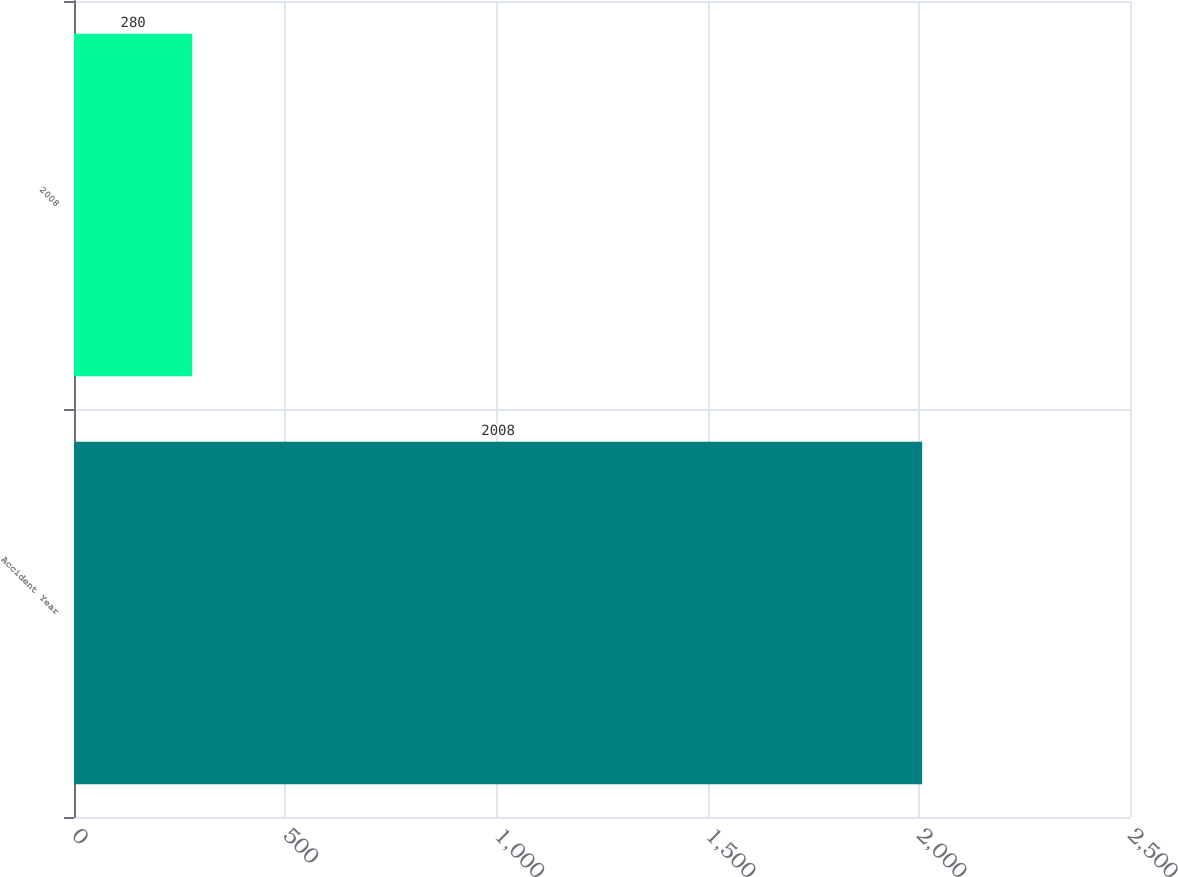Convert chart to OTSL. <chart><loc_0><loc_0><loc_500><loc_500><bar_chart><fcel>Accident Year<fcel>2008<nl><fcel>2008<fcel>280<nl></chart> 